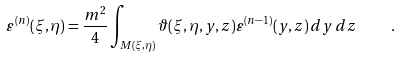<formula> <loc_0><loc_0><loc_500><loc_500>\varepsilon ^ { ( n ) } ( \xi , \eta ) = \frac { m ^ { 2 } } { 4 } \int _ { M ( \xi , \eta ) } \vartheta ( \xi , \eta , y , z ) \varepsilon ^ { ( n - 1 ) } ( y , z ) \, d y \, d z \quad .</formula> 